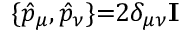<formula> <loc_0><loc_0><loc_500><loc_500>\{ \hat { p } _ { \mu } , \hat { p } _ { \nu } \} { = } 2 \delta _ { \mu \nu } I</formula> 